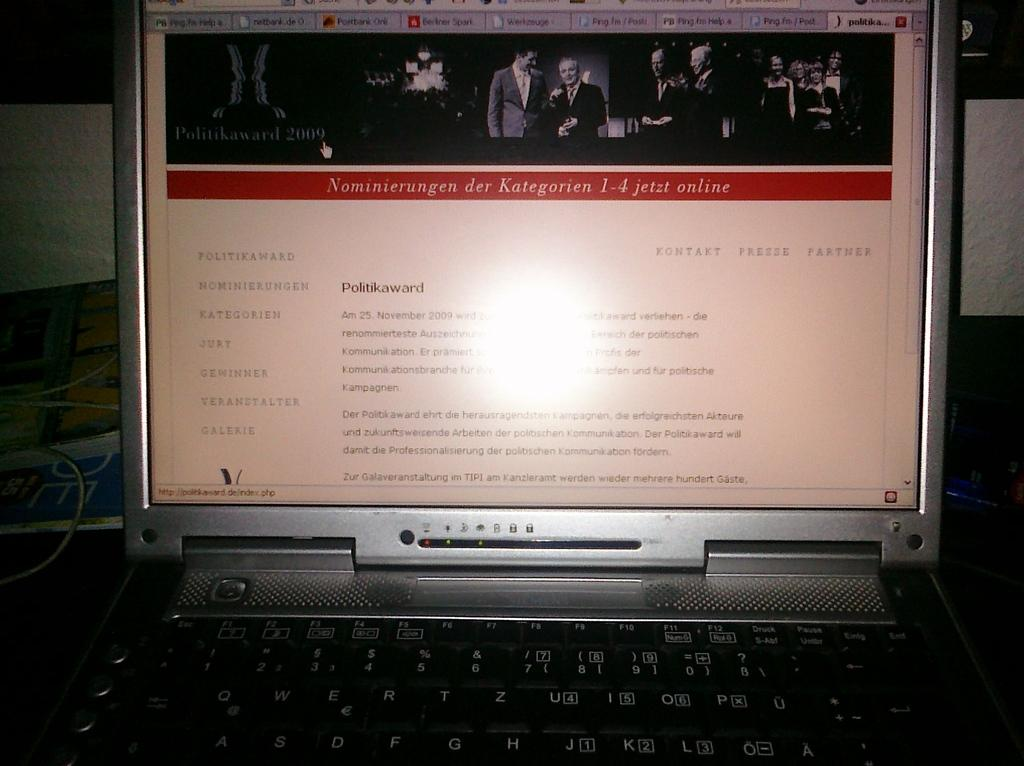Provide a one-sentence caption for the provided image. Laptop monitor showing a screen that says Politikaward. ". 